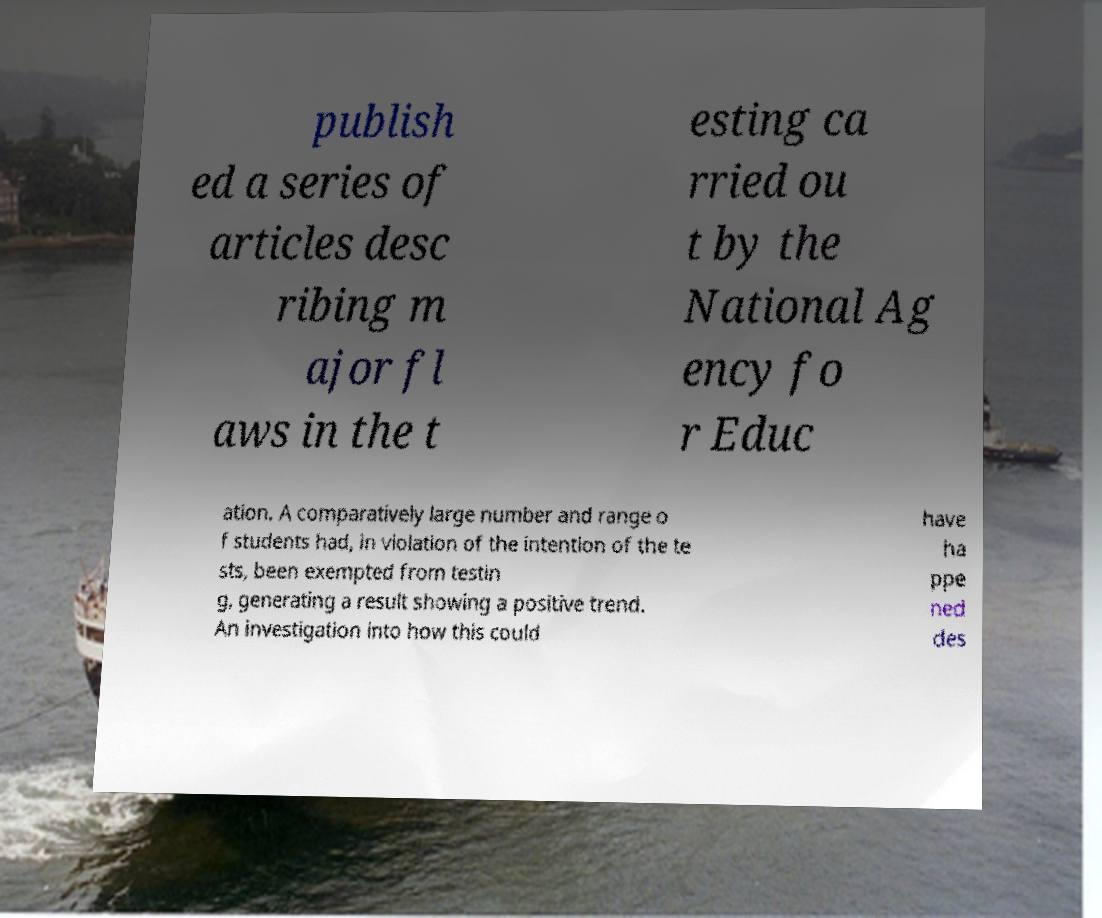There's text embedded in this image that I need extracted. Can you transcribe it verbatim? publish ed a series of articles desc ribing m ajor fl aws in the t esting ca rried ou t by the National Ag ency fo r Educ ation. A comparatively large number and range o f students had, in violation of the intention of the te sts, been exempted from testin g, generating a result showing a positive trend. An investigation into how this could have ha ppe ned des 